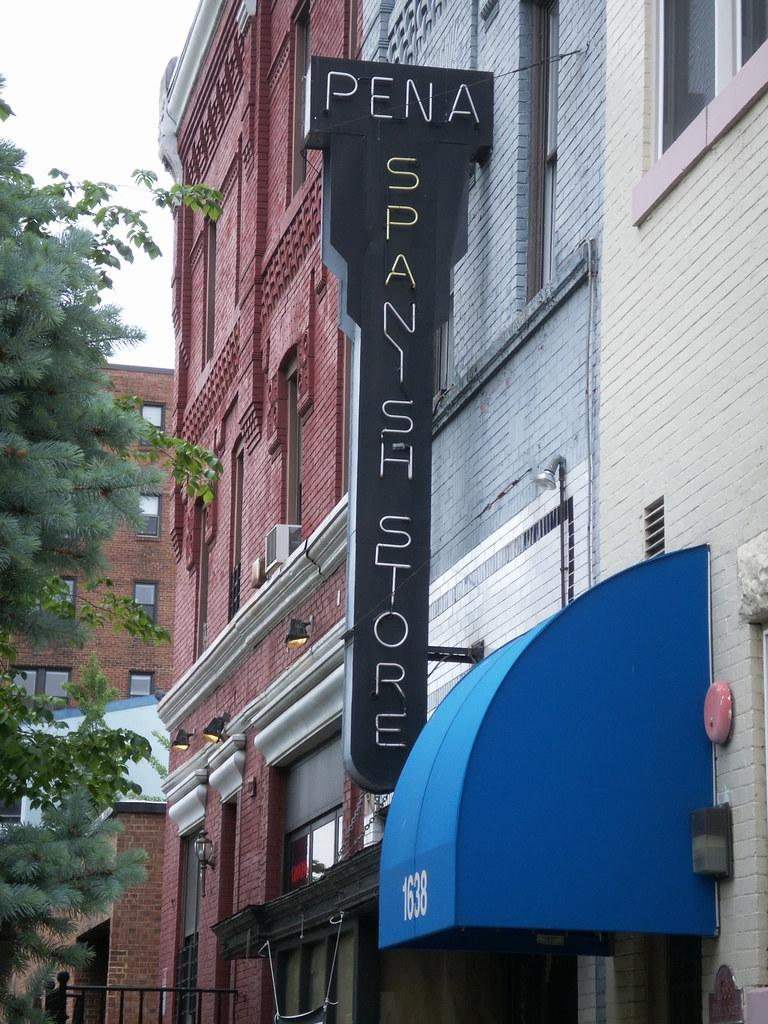What type of structures can be seen in the image? There are buildings with windows in the image. What is written or displayed on the signboard in the image? The signboard in the image has text, but we cannot determine the exact message without more information. What type of barrier is present in the image? There is a fence in the image. What is covering the top of the buildings in the image? There is a roof in the image. What type of illumination is present in the image? There are lights in the image. What type of plant is visible in the image? There is a tree in the image. How would you describe the sky in the image? The sky is visible in the image and appears cloudy. What type of coil is wrapped around the tree in the image? There is no coil present around the tree in the image. How does the nerve affect the buildings in the image? There is no mention of a nerve in the image, and it would not have any effect on the buildings. 